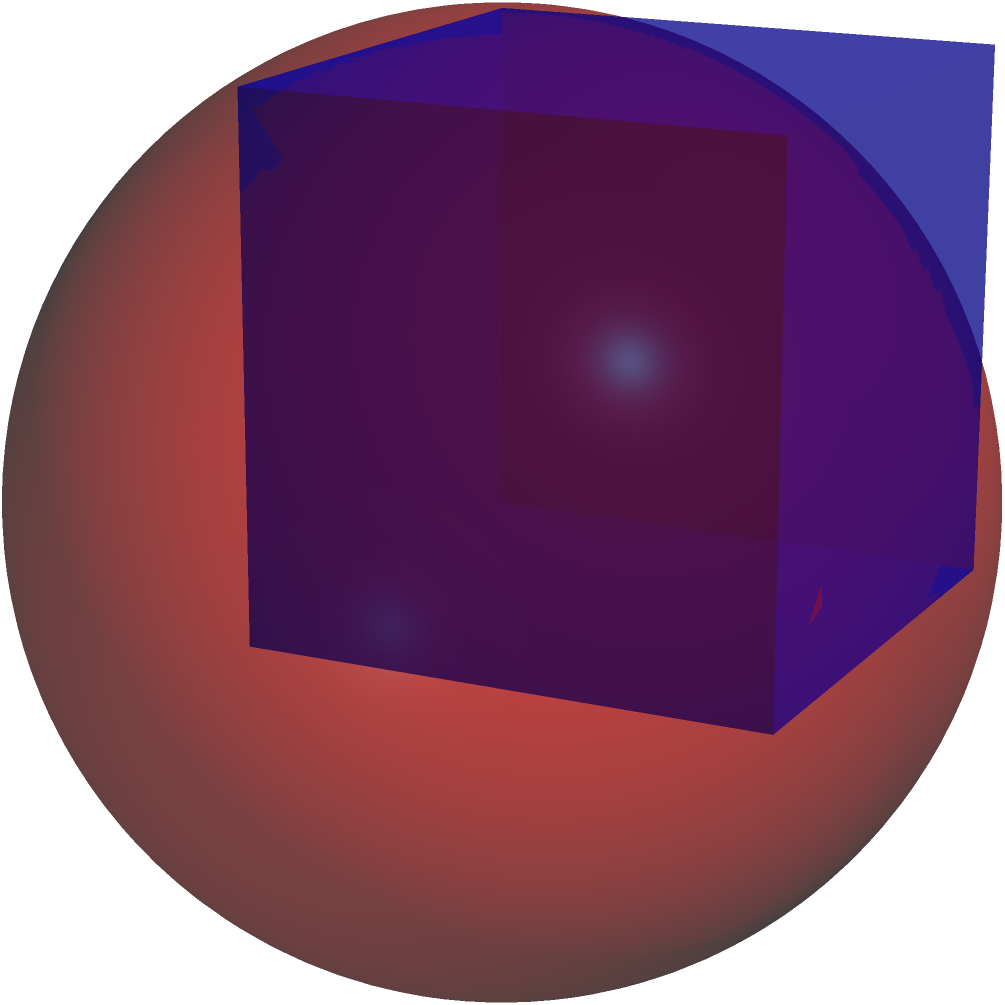In 3D object classification for robotics applications, which feature would be most effective in distinguishing a cube from a sphere in wireframe renderings? To distinguish a cube from a sphere in wireframe renderings, we need to consider their fundamental geometric properties:

1. Edges: A cube has 12 straight edges, while a sphere has no edges in its ideal form.

2. Vertices: A cube has 8 distinct vertices, whereas a sphere has no vertices.

3. Faces: A cube has 6 flat faces, while a sphere has a continuous curved surface.

4. Symmetry: Both objects are symmetrical, but in different ways. A cube has 6 square faces with 90-degree angles, while a sphere is perfectly round.

5. Wireframe representation:
   - Cube: Appears as a set of connected straight lines forming a box shape.
   - Sphere: Typically represented by a series of circular cross-sections or latitude/longitude lines.

6. Silhouette: The outline of a cube changes significantly as it rotates, showing different polygonal shapes. A sphere's silhouette remains circular from any angle.

7. Corner detection: A cube will have sharp corners where edges meet, while a sphere will not have any detectable corners.

Among these features, the presence of straight edges and distinct vertices in a cube's wireframe rendering provides the most reliable and computationally efficient method for classification. Edge detection algorithms can easily identify the straight lines of a cube, which are absent in a sphere's wireframe.

Therefore, the most effective feature for distinguishing a cube from a sphere in wireframe renderings would be the presence of straight edges.
Answer: Presence of straight edges 